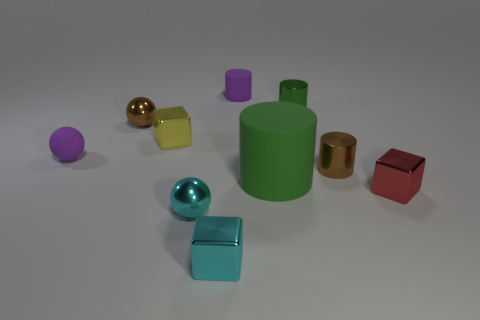Subtract all tiny shiny spheres. How many spheres are left? 1 Subtract all green cylinders. How many cylinders are left? 2 Subtract all blue balls. How many green cylinders are left? 2 Subtract 2 balls. How many balls are left? 1 Subtract all spheres. How many objects are left? 7 Add 6 tiny green cylinders. How many tiny green cylinders exist? 7 Subtract 1 cyan balls. How many objects are left? 9 Subtract all yellow cylinders. Subtract all red cubes. How many cylinders are left? 4 Subtract all cyan objects. Subtract all tiny metal things. How many objects are left? 1 Add 1 small red metal objects. How many small red metal objects are left? 2 